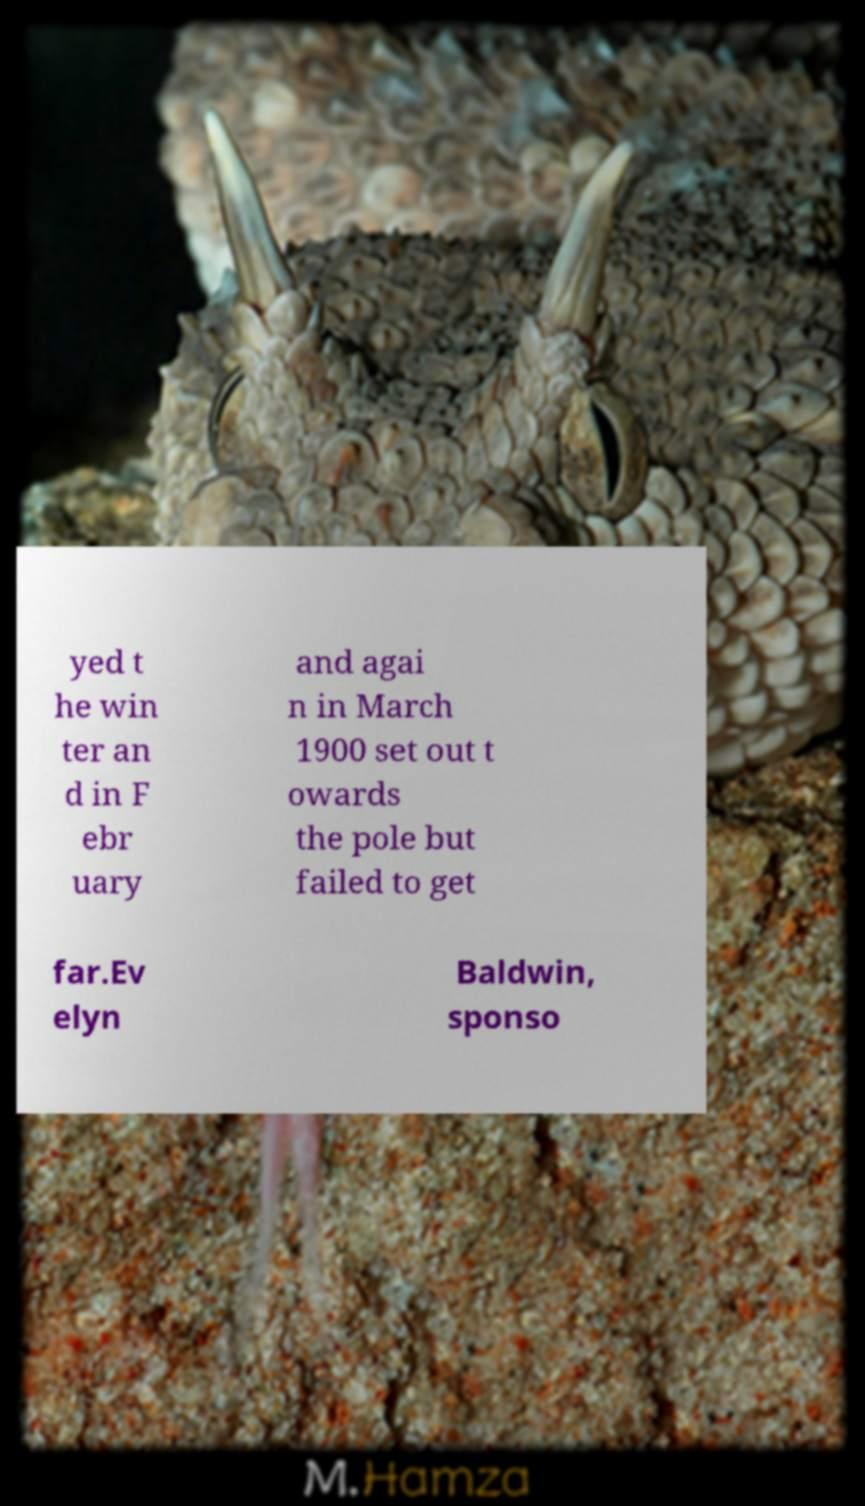There's text embedded in this image that I need extracted. Can you transcribe it verbatim? yed t he win ter an d in F ebr uary and agai n in March 1900 set out t owards the pole but failed to get far.Ev elyn Baldwin, sponso 